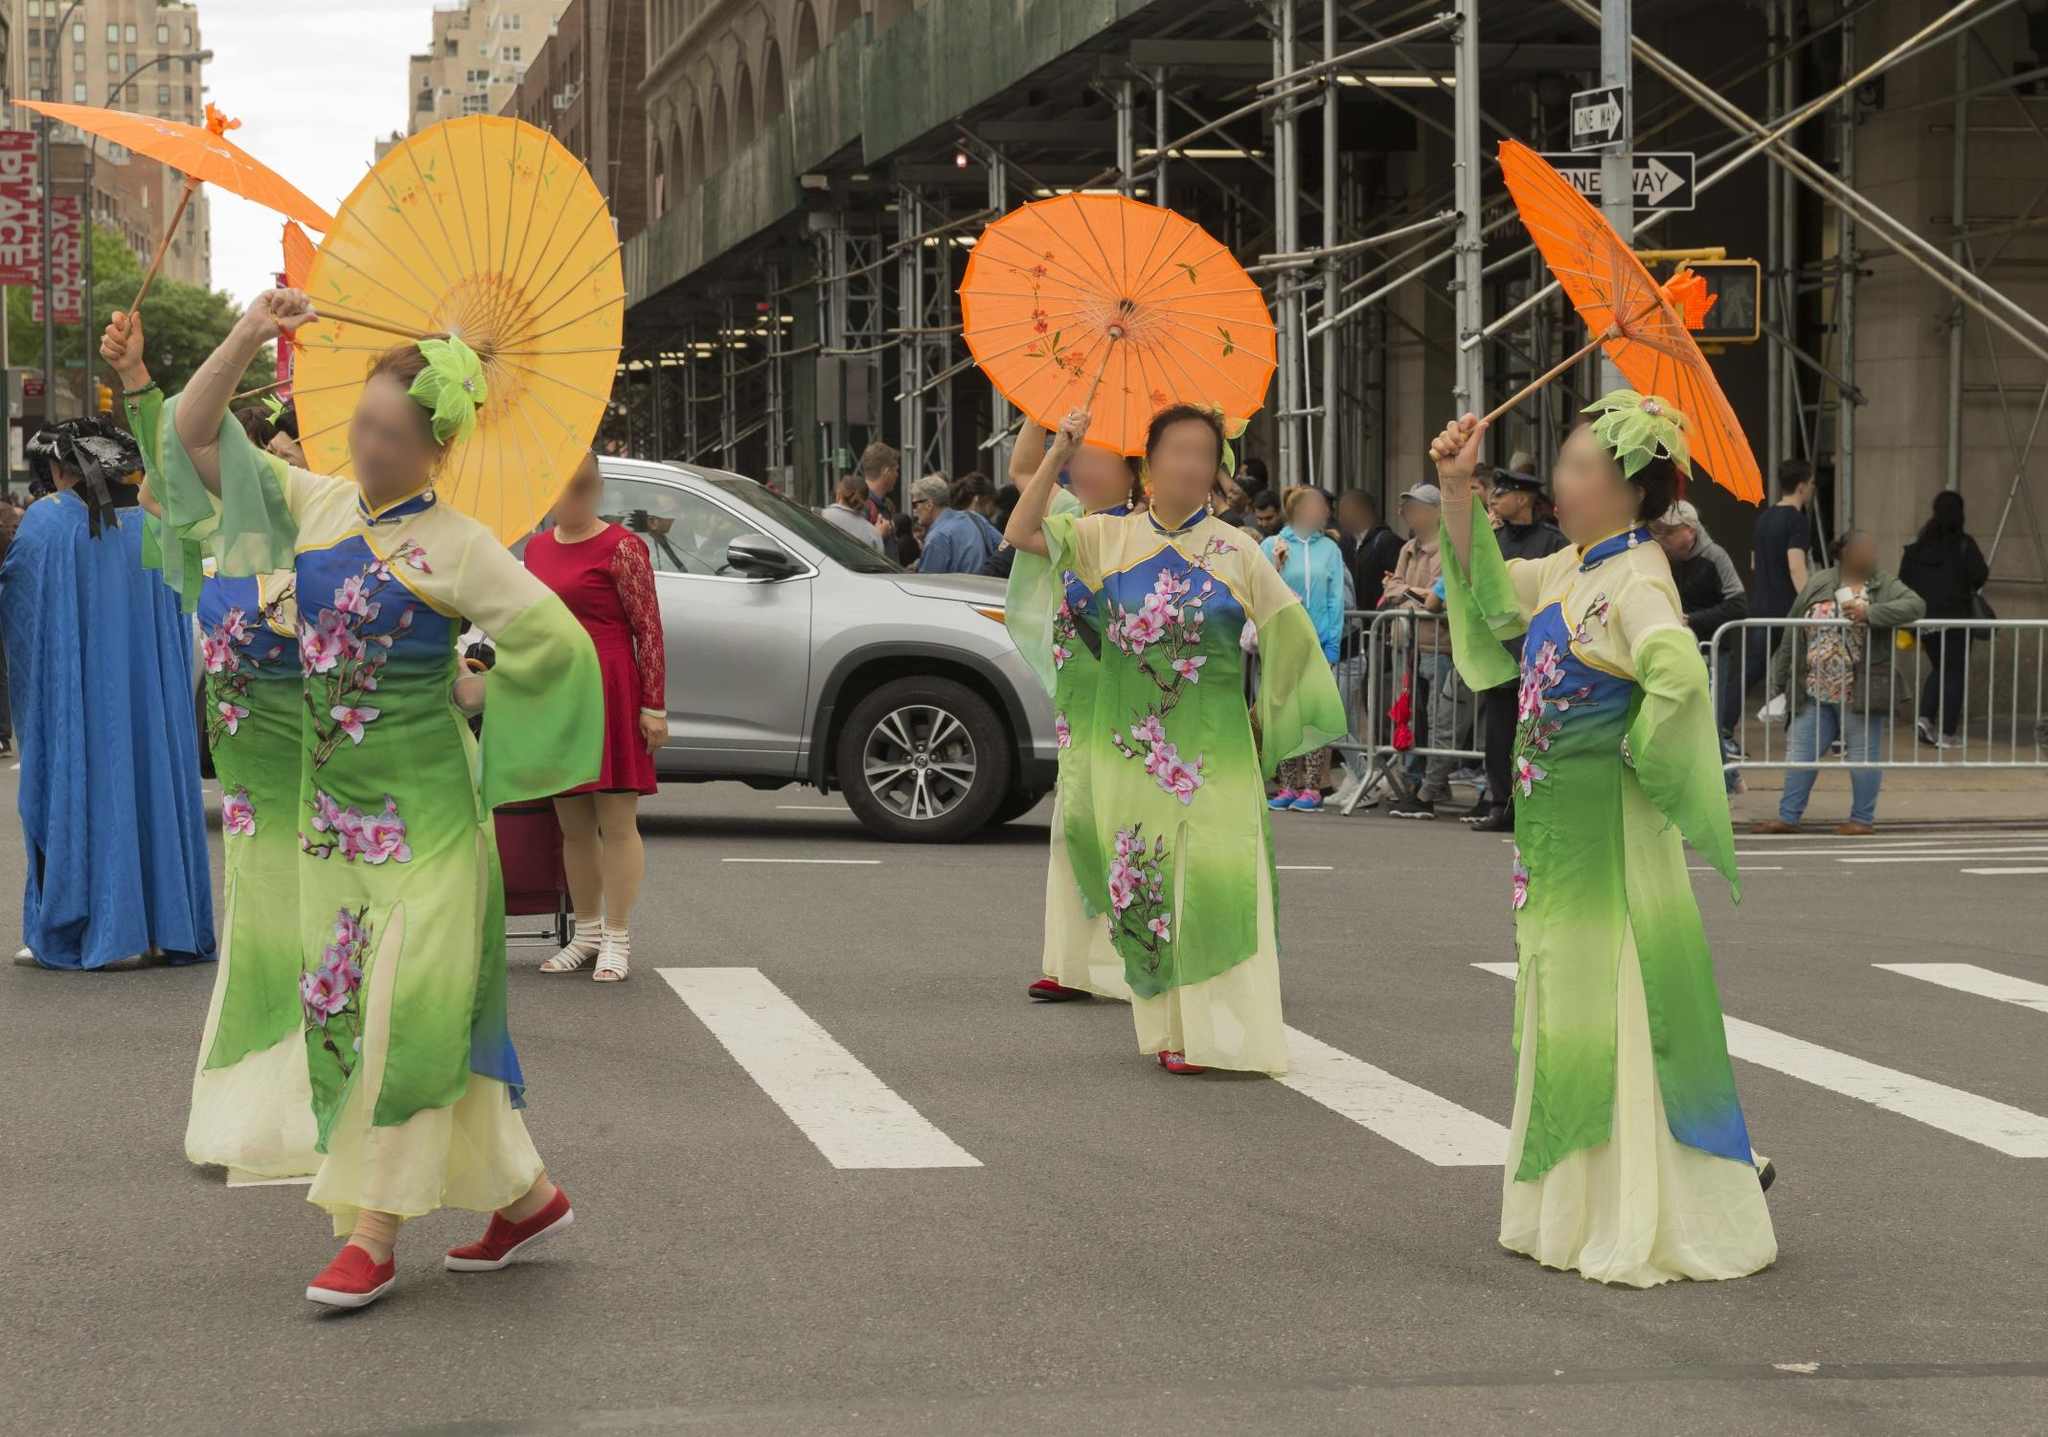Imagine being a child watching this parade. What might you experience? As a child, witnessing the parade would be a mesmerizing experience filled with wonder and awe. The colorful kimonos and bright parasols would capture your imagination, making you feel as though you've stepped into a fairy tale. The graceful movements of the women, the cheerful crowd, and the lively city backdrop would create an exciting atmosphere. You might feel a sense of joy and curiosity, eager to join in the celebration, perhaps dreaming of one day wearing such beautiful attire and participating in the parade yourself. Standing on tiptoes, you can barely contain your excitement as the vibrant parade passes by. The dazzling colors, the rhythmic sounds of traditional music, and the cheerful chatter of the crowd create a magical moment. The women in their flowing green kimonos seem like elegant princesses from a distant kingdom, their orange and yellow parasols spinning like fairy wands. Every detail is a spark of inspiration, filling you with joy and leaving a lasting impression of this enchanted day. 